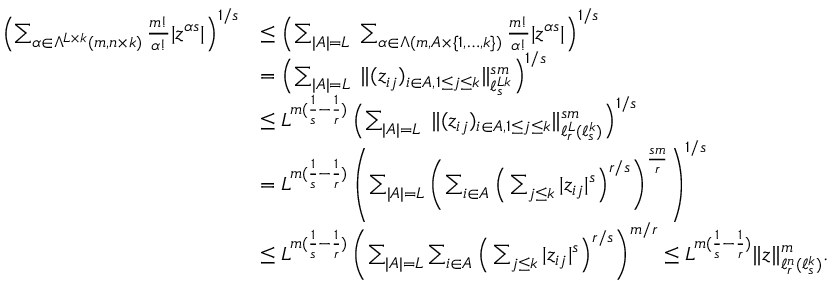Convert formula to latex. <formula><loc_0><loc_0><loc_500><loc_500>\begin{array} { r l } { \left ( \sum _ { \alpha \in \Lambda ^ { L \times k } ( m , n \times k ) } \frac { m ! } { \alpha ! } | z ^ { \alpha s } | \right ) ^ { 1 / s } } & { \leq \left ( \sum _ { | A | = L } \, \sum _ { \alpha \in \Lambda ( m , A \times \{ 1 , \dots , k \} ) } \frac { m ! } { \alpha ! } | z ^ { \alpha s } | \right ) ^ { 1 / s } } \\ & { = \left ( \sum _ { | A | = L } \, \| ( z _ { i j } ) _ { i \in A , 1 \leq j \leq k } \| _ { \ell _ { s } ^ { L k } } ^ { s m } \right ) ^ { 1 / s } } \\ & { \leq L ^ { m ( \frac { 1 } s } - \frac { 1 } r } ) } \left ( \sum _ { | A | = L } \, \| ( z _ { i j } ) _ { i \in A , 1 \leq j \leq k } \| _ { \ell _ { r } ^ { L } ( \ell _ { s } ^ { k } ) } ^ { s m } \right ) ^ { 1 / s } } \\ & { = L ^ { m ( \frac { 1 } s } - \frac { 1 } r } ) } \left ( \sum _ { | A | = L } \left ( \sum _ { i \in A } \left ( \sum _ { j \leq k } | z _ { i j } | ^ { s } \right ) ^ { r / s } \right ) ^ { \frac { s m } { r } } \right ) ^ { 1 / s } } \\ & { \leq L ^ { m ( \frac { 1 } s } - \frac { 1 } r } ) } \left ( \sum _ { | A | = L } \sum _ { i \in A } \left ( \sum _ { j \leq k } | z _ { i j } | ^ { s } \right ) ^ { r / s } \right ) ^ { m / r } \leq L ^ { m ( \frac { 1 } s } - \frac { 1 } r } ) } \| z \| _ { \ell _ { r } ^ { n } ( \ell _ { s } ^ { k } ) } ^ { m } . } \end{array}</formula> 